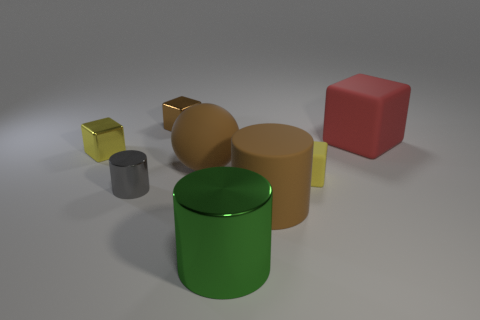Subtract 1 blocks. How many blocks are left? 3 Add 2 large cyan matte spheres. How many objects exist? 10 Subtract all balls. How many objects are left? 7 Add 1 tiny blocks. How many tiny blocks are left? 4 Add 7 big balls. How many big balls exist? 8 Subtract 2 yellow blocks. How many objects are left? 6 Subtract all small brown objects. Subtract all metallic objects. How many objects are left? 3 